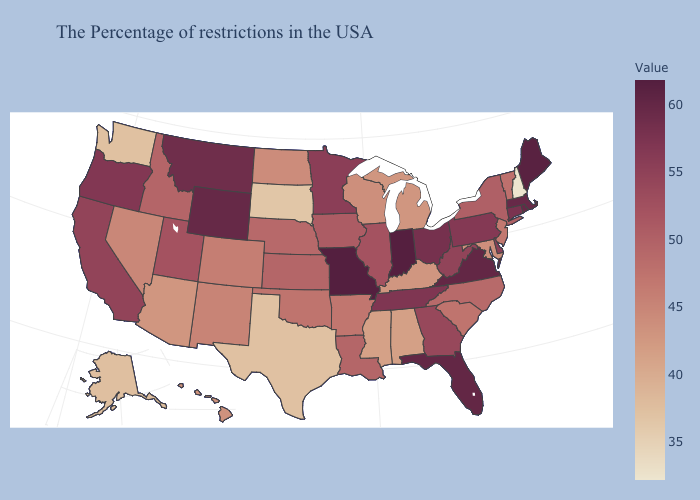Does Oregon have a lower value than Arkansas?
Keep it brief. No. Among the states that border Mississippi , which have the highest value?
Give a very brief answer. Tennessee. Which states have the lowest value in the USA?
Concise answer only. New Hampshire. Which states have the lowest value in the USA?
Answer briefly. New Hampshire. Among the states that border California , which have the lowest value?
Quick response, please. Arizona. Does New Hampshire have the lowest value in the USA?
Keep it brief. Yes. 